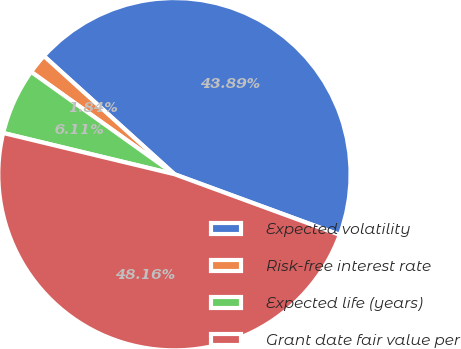Convert chart to OTSL. <chart><loc_0><loc_0><loc_500><loc_500><pie_chart><fcel>Expected volatility<fcel>Risk-free interest rate<fcel>Expected life (years)<fcel>Grant date fair value per<nl><fcel>43.89%<fcel>1.84%<fcel>6.11%<fcel>48.16%<nl></chart> 